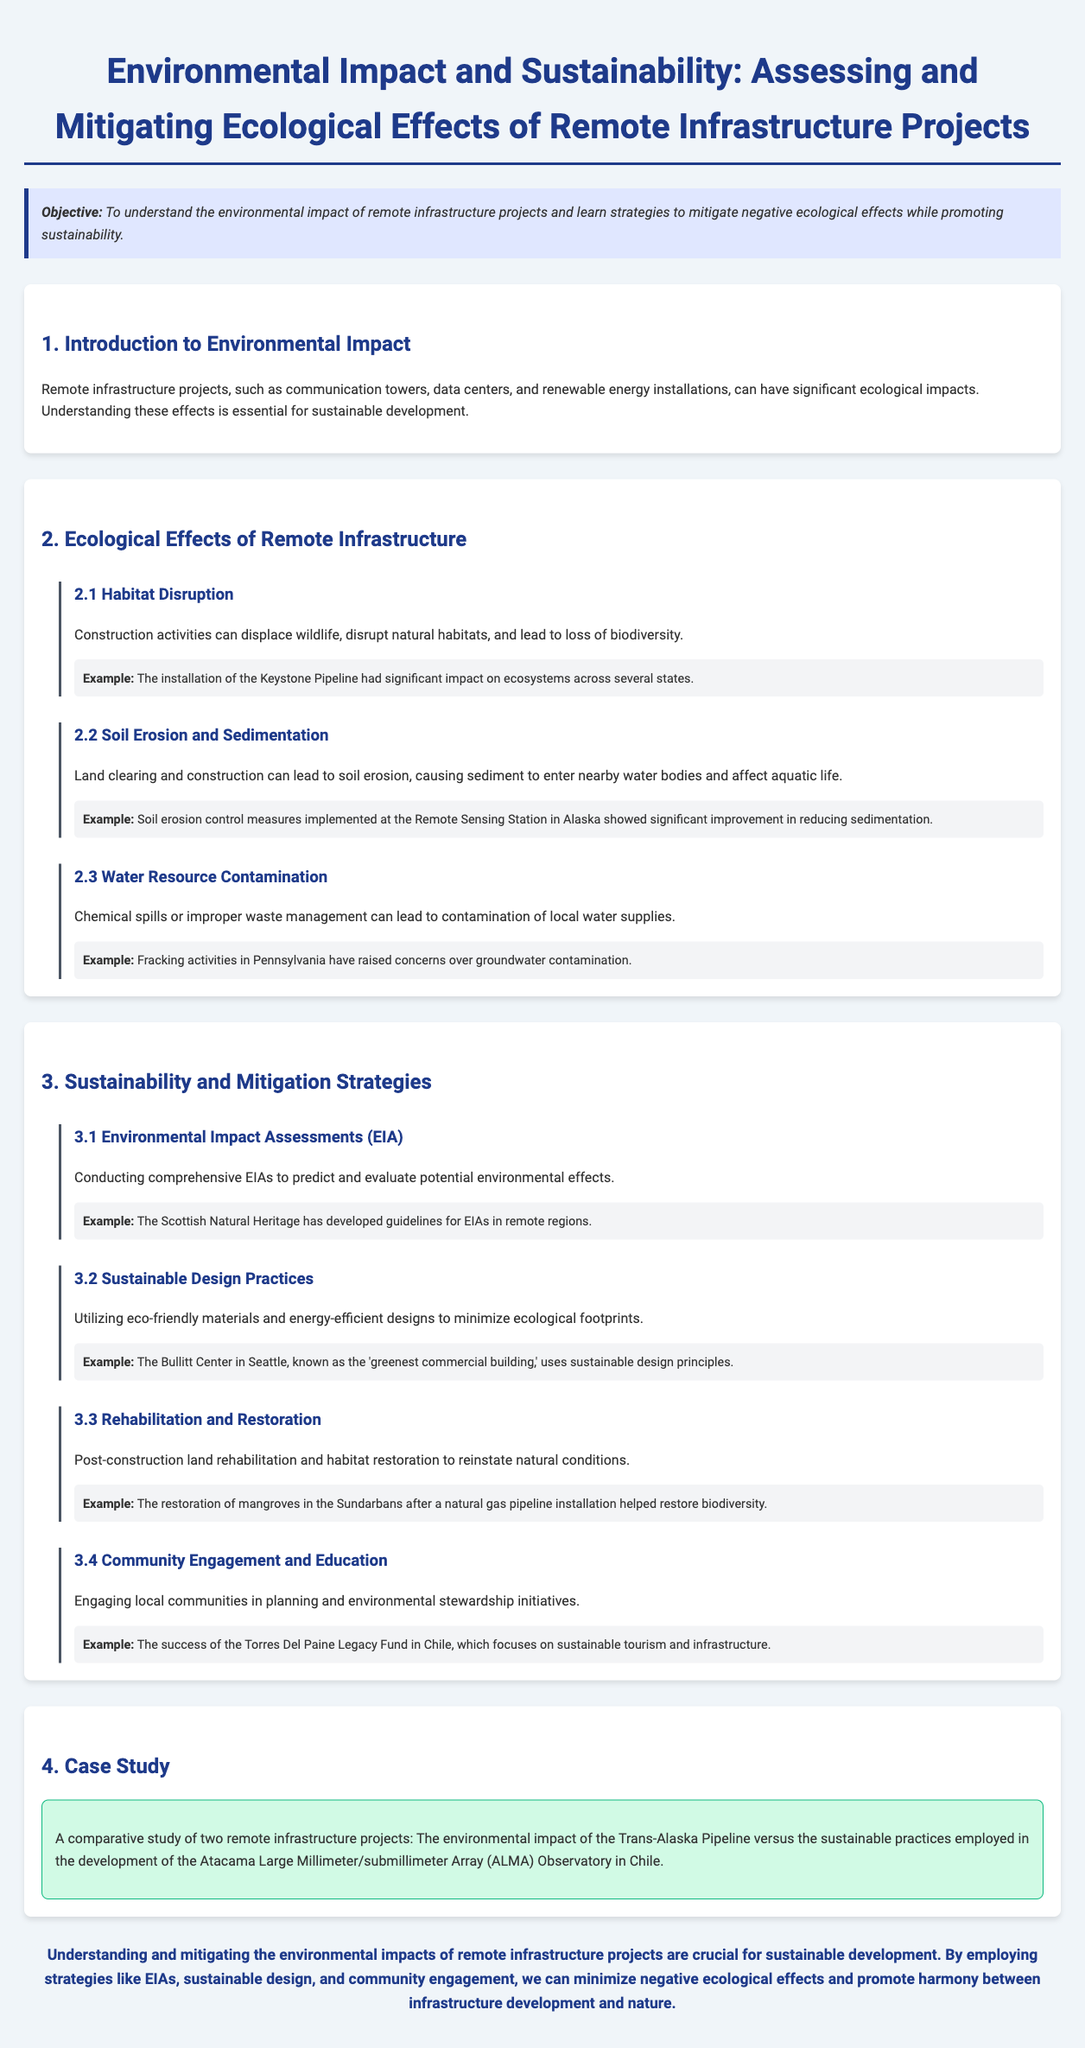what is the objective of the lesson plan? The objective is to understand the environmental impact of remote infrastructure projects and learn strategies to mitigate negative ecological effects while promoting sustainability.
Answer: To understand the environmental impact of remote infrastructure projects and learn strategies to mitigate negative ecological effects while promoting sustainability what is a significant ecological effect of construction activities? This is mentioned as habitat disruption, leading to wildlife displacement and loss of biodiversity.
Answer: Habitat disruption what is one strategy for sustainability listed in the document? The document includes conducting Environmental Impact Assessments (EIA) as one of the sustainability strategies.
Answer: Environmental Impact Assessments (EIA) who developed guidelines for EIAs in remote regions? The Scottish Natural Heritage is mentioned as the organization that developed guidelines for EIAs.
Answer: Scottish Natural Heritage what example is provided for soil erosion control? The example of soil erosion control measures implemented at the Remote Sensing Station in Alaska is provided.
Answer: Remote Sensing Station in Alaska how many subsections are under "Ecological Effects of Remote Infrastructure"? There are three subsections listed under this section, including habitat disruption, soil erosion and sedimentation, and water resource contamination.
Answer: Three what type of building is the Bullitt Center referred to in the document? It is referred to as the 'greenest commercial building,' which uses sustainable design principles.
Answer: 'greenest commercial building' what specific project is compared to the Atacama Large Millimeter/submillimeter Array (ALMA) Observatory in the case study? The case study compares it with the Trans-Alaska Pipeline.
Answer: Trans-Alaska Pipeline what is one community engagement initiative mentioned? The Torres Del Paine Legacy Fund in Chile is mentioned as a successful community engagement initiative.
Answer: Torres Del Paine Legacy Fund 